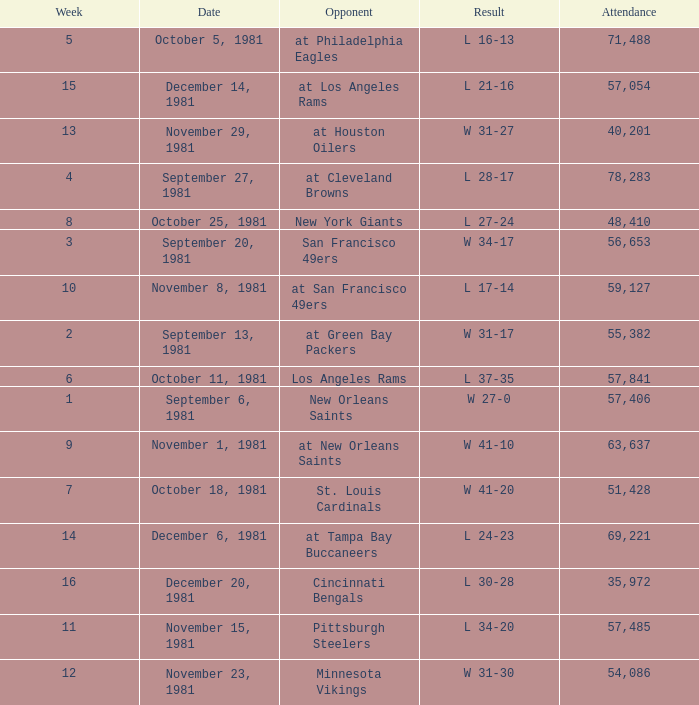What was the average number of attendance for the game on November 29, 1981 played after week 13? None. 